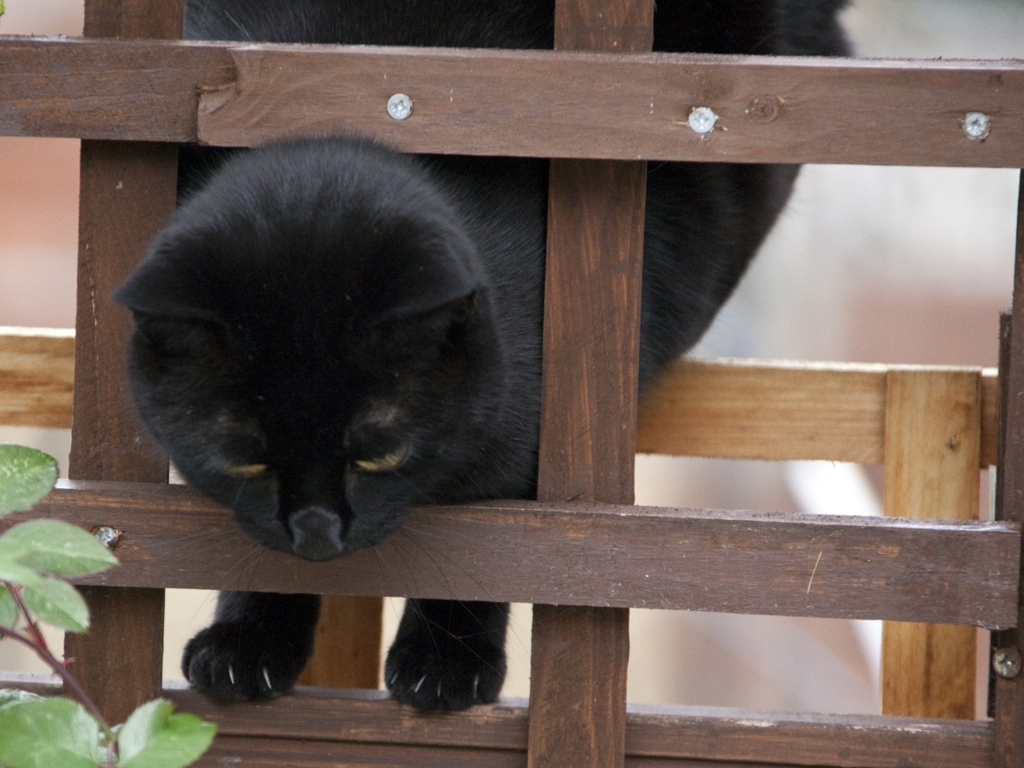Can you describe the mood created by this image and what elements contribute to it? The image evokes a sense of curiosity and anticipation, as the black cat peers through the gaps in the wooden lattice. The dark color of the cat against the brown wooden background creates a striking contrast, while the surrounding foliage adds a touch of natural serenity. There's also an element of mystery, often attributed to black cats in various cultures, enhancing the image's enigmatic appeal. 